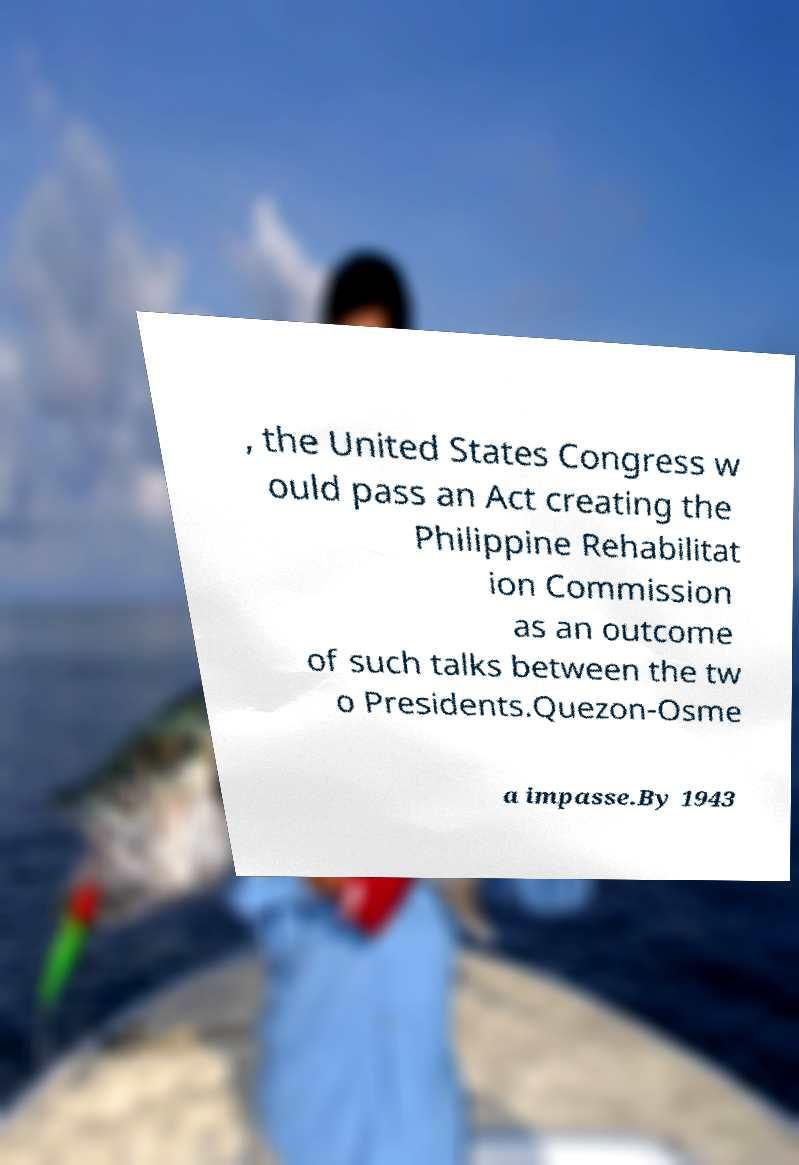Please read and relay the text visible in this image. What does it say? , the United States Congress w ould pass an Act creating the Philippine Rehabilitat ion Commission as an outcome of such talks between the tw o Presidents.Quezon-Osme a impasse.By 1943 